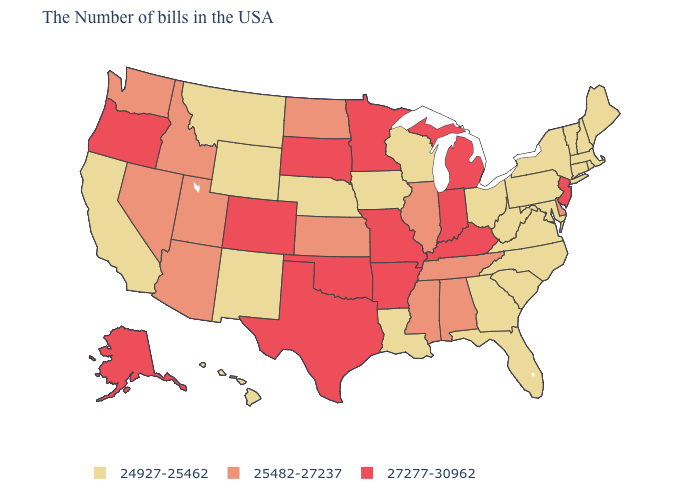Name the states that have a value in the range 27277-30962?
Keep it brief. New Jersey, Michigan, Kentucky, Indiana, Missouri, Arkansas, Minnesota, Oklahoma, Texas, South Dakota, Colorado, Oregon, Alaska. Does Oregon have the highest value in the West?
Concise answer only. Yes. Among the states that border Pennsylvania , which have the lowest value?
Concise answer only. New York, Maryland, West Virginia, Ohio. What is the value of Colorado?
Be succinct. 27277-30962. What is the highest value in states that border South Carolina?
Answer briefly. 24927-25462. Does Colorado have the highest value in the USA?
Quick response, please. Yes. What is the value of Hawaii?
Give a very brief answer. 24927-25462. Does Louisiana have the highest value in the South?
Keep it brief. No. What is the highest value in states that border Iowa?
Write a very short answer. 27277-30962. What is the highest value in states that border Delaware?
Write a very short answer. 27277-30962. What is the value of Texas?
Be succinct. 27277-30962. Does Vermont have the highest value in the USA?
Concise answer only. No. Name the states that have a value in the range 24927-25462?
Write a very short answer. Maine, Massachusetts, Rhode Island, New Hampshire, Vermont, Connecticut, New York, Maryland, Pennsylvania, Virginia, North Carolina, South Carolina, West Virginia, Ohio, Florida, Georgia, Wisconsin, Louisiana, Iowa, Nebraska, Wyoming, New Mexico, Montana, California, Hawaii. What is the value of New York?
Concise answer only. 24927-25462. Which states have the highest value in the USA?
Quick response, please. New Jersey, Michigan, Kentucky, Indiana, Missouri, Arkansas, Minnesota, Oklahoma, Texas, South Dakota, Colorado, Oregon, Alaska. 